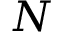<formula> <loc_0><loc_0><loc_500><loc_500>N</formula> 